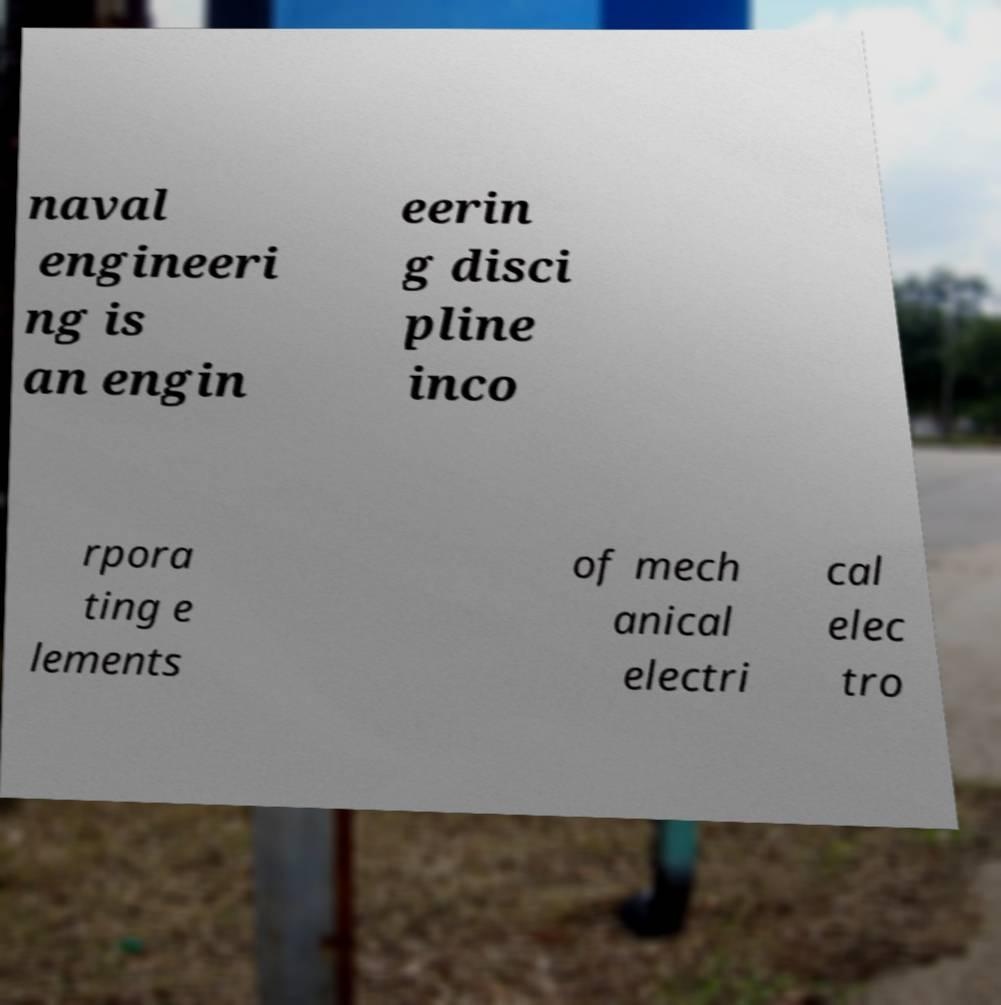Please read and relay the text visible in this image. What does it say? naval engineeri ng is an engin eerin g disci pline inco rpora ting e lements of mech anical electri cal elec tro 